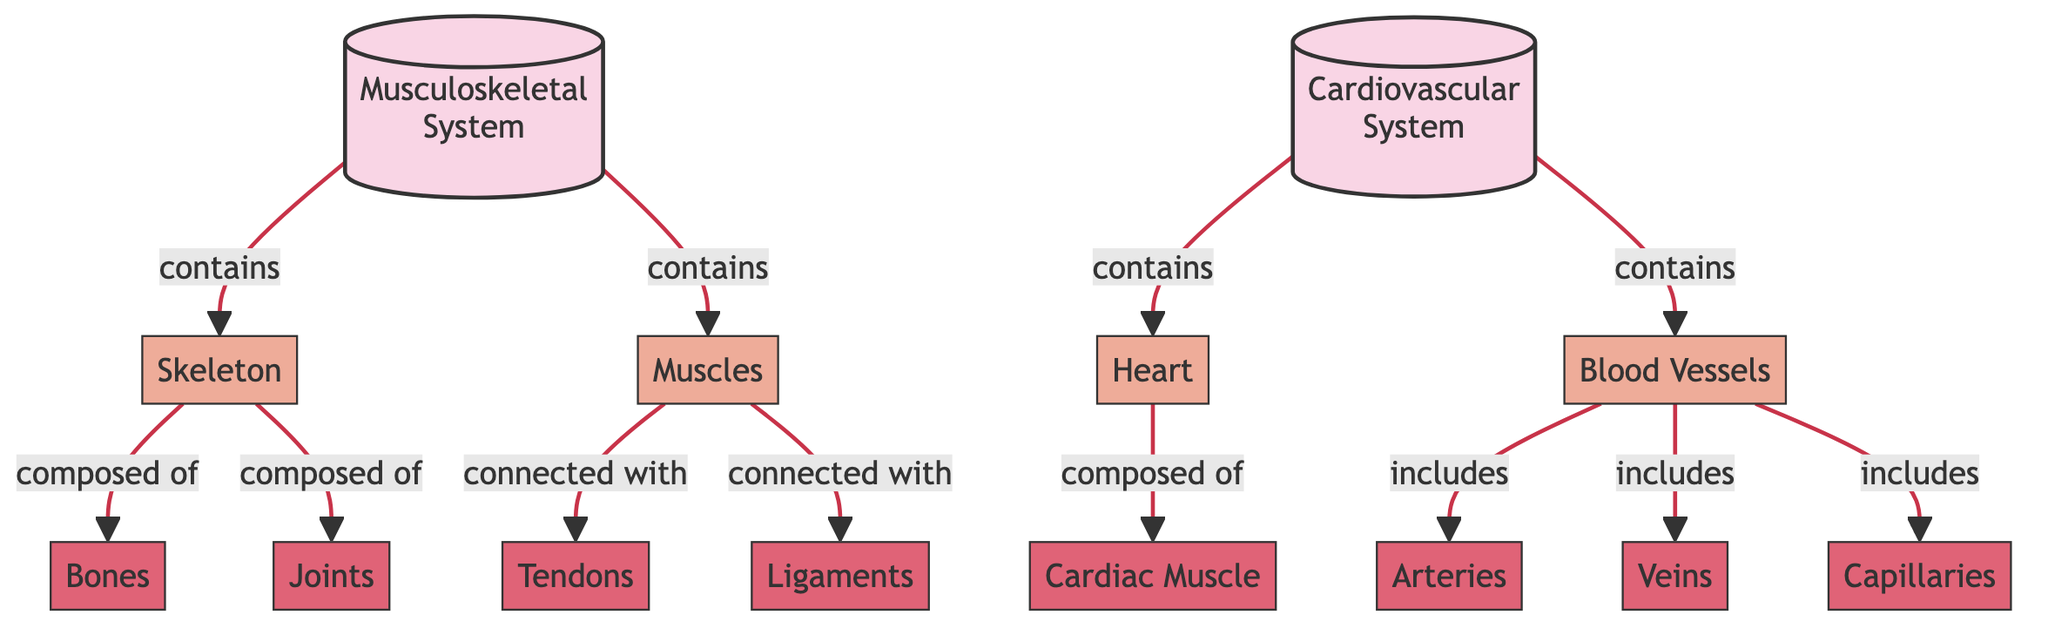What are the two main systems illustrated in the diagram? The diagram clearly labels two main systems: the Musculoskeletal System and the Cardiovascular System.
Answer: Musculoskeletal System, Cardiovascular System How many components are included in the Musculoskeletal System? The Musculoskeletal System encompasses two main components: Skeleton and Muscles. Therefore, the count is two.
Answer: 2 What are the three types of Blood Vessels mentioned in the diagram? The diagram lists Blood Vessels as including three specific types: Arteries, Veins, and Capillaries.
Answer: Arteries, Veins, Capillaries What connects Muscles to the Skeleton? The role of Tendons is to connect Muscles with the Skeleton, as depicted in the flowchart.
Answer: Tendons What type of muscle composes the Heart? The diagram specifies that the Heart is composed of Cardiac Muscle, distinguishing it from skeletal and smooth muscle types.
Answer: Cardiac Muscle How many subcomponents does the Skeleton have? The Skeleton consists of four subcomponents: Bones, Joints, Tendons, and Ligaments. Thus, the total is four.
Answer: 4 What is directly connected to Muscles, apart from the Skeleton? Ligaments connect Muscles, specifically indicated in the diagram as a connection. Thus, the answer is Ligaments.
Answer: Ligaments Which system contains the Heart? The diagram identifies that the Cardiovascular System contains the Heart as one of its primary components.
Answer: Cardiovascular System What is the relationship between Blood Vessels and the Cardiovascular System? Blood Vessels are a component that falls under the Cardiovascular System, as shown in the diagram.
Answer: Blood Vessels 